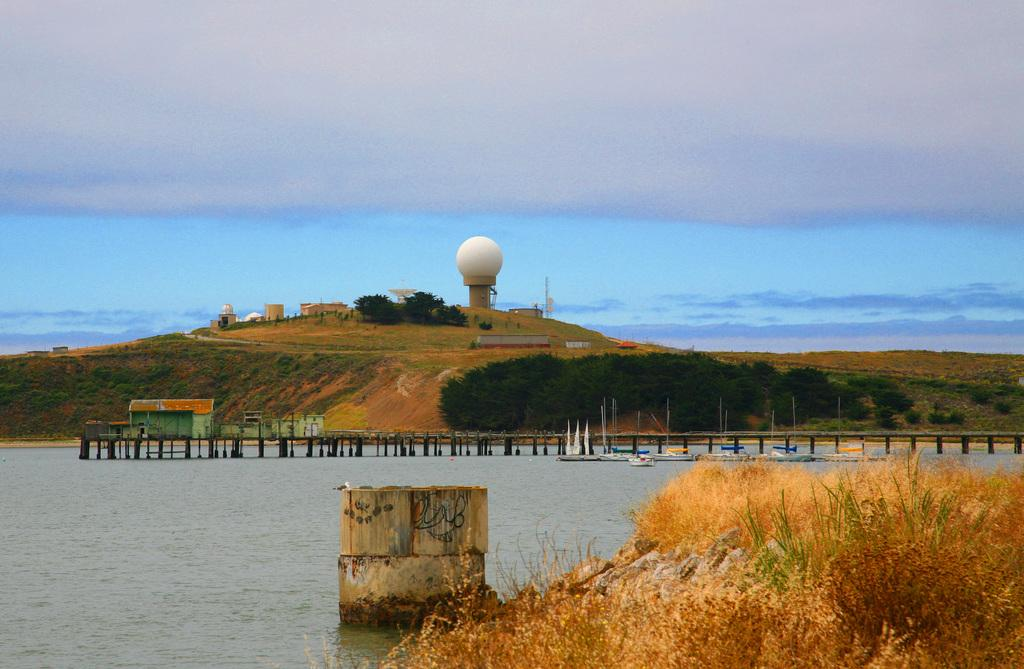What type of structures can be seen in the image? There are buildings in the image. What natural elements are present in the image? There are trees, hills, and water in the image. What type of transportation is visible on the water? There are boats on the water in the image. What type of man-made structure connects two areas in the image? There is a walkway bridge in the image. What type of vegetation can be seen in the image besides trees? There are bushes in the image. What part of the natural environment is visible in the background of the image? The sky is visible in the background of the image. What can be seen in the sky? There are clouds in the sky. Where are the dolls placed in the image? There are no dolls present in the image. What type of trip can be taken using the walkway bridge in the image? The walkway bridge is not a mode of transportation for a trip; it is a structure connecting two areas. 